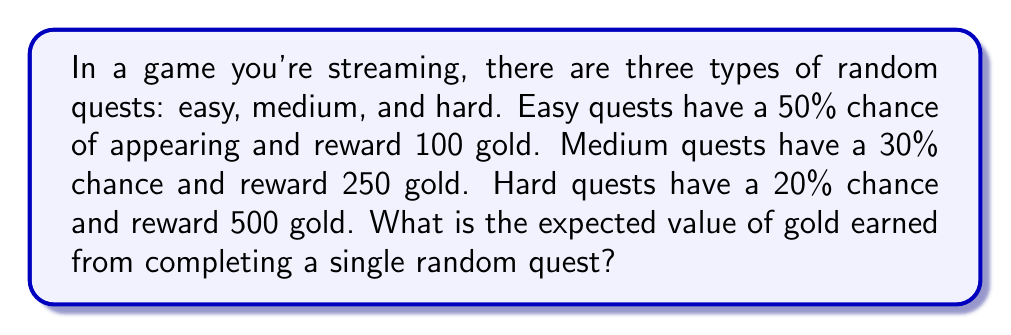Teach me how to tackle this problem. To solve this problem, we'll use the concept of expected value from probability theory. The expected value is calculated by multiplying each possible outcome by its probability and then summing these products.

Let's break it down step-by-step:

1) First, let's define our random variable X as the amount of gold earned from a single quest.

2) We have three possible outcomes:
   - Easy quest (E): P(E) = 0.50, X(E) = 100
   - Medium quest (M): P(M) = 0.30, X(M) = 250
   - Hard quest (H): P(H) = 0.20, X(H) = 500

3) The expected value formula is:
   $$E(X) = \sum_{i} x_i \cdot P(X = x_i)$$

4) Applying this formula to our scenario:
   $$E(X) = 100 \cdot 0.50 + 250 \cdot 0.30 + 500 \cdot 0.20$$

5) Let's calculate each term:
   - Easy: $100 \cdot 0.50 = 50$
   - Medium: $250 \cdot 0.30 = 75$
   - Hard: $500 \cdot 0.20 = 100$

6) Now, sum up all the terms:
   $$E(X) = 50 + 75 + 100 = 225$$

Therefore, the expected value of gold earned from completing a single random quest is 225 gold.
Answer: 225 gold 